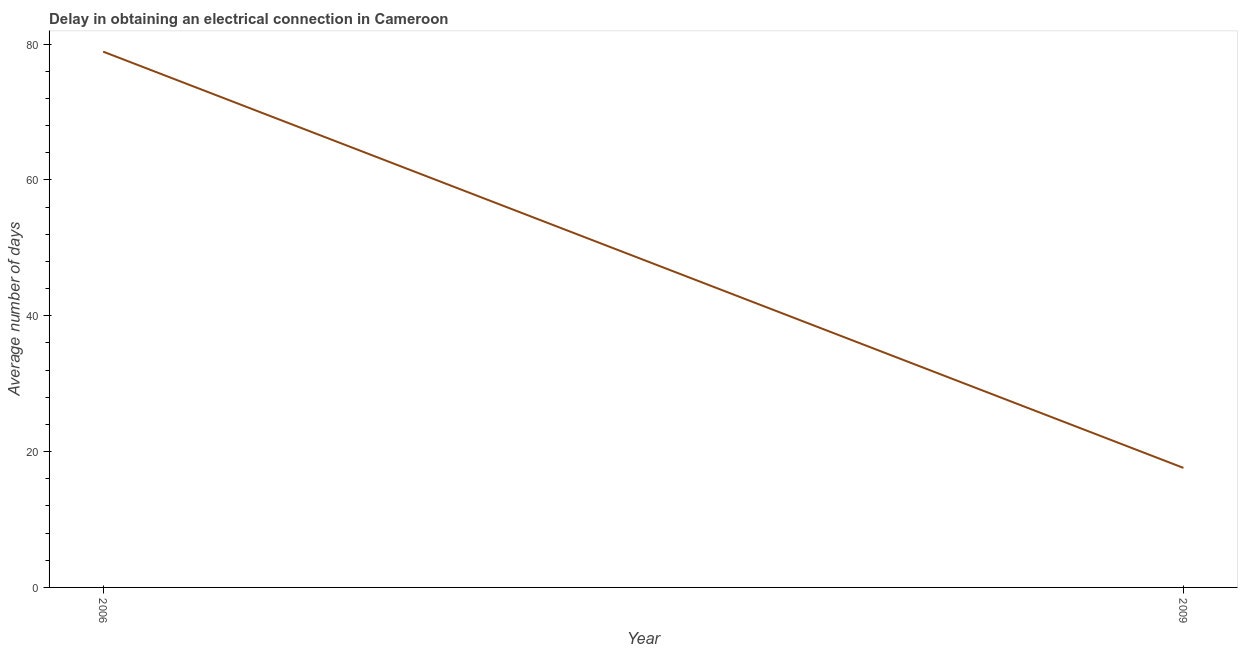Across all years, what is the maximum dalay in electrical connection?
Offer a very short reply. 78.9. In which year was the dalay in electrical connection minimum?
Keep it short and to the point. 2009. What is the sum of the dalay in electrical connection?
Your answer should be compact. 96.5. What is the difference between the dalay in electrical connection in 2006 and 2009?
Your answer should be very brief. 61.3. What is the average dalay in electrical connection per year?
Offer a very short reply. 48.25. What is the median dalay in electrical connection?
Give a very brief answer. 48.25. In how many years, is the dalay in electrical connection greater than 32 days?
Provide a short and direct response. 1. Do a majority of the years between 2009 and 2006 (inclusive) have dalay in electrical connection greater than 52 days?
Keep it short and to the point. No. What is the ratio of the dalay in electrical connection in 2006 to that in 2009?
Ensure brevity in your answer.  4.48. Is the dalay in electrical connection in 2006 less than that in 2009?
Your response must be concise. No. In how many years, is the dalay in electrical connection greater than the average dalay in electrical connection taken over all years?
Provide a succinct answer. 1. How many years are there in the graph?
Keep it short and to the point. 2. What is the difference between two consecutive major ticks on the Y-axis?
Give a very brief answer. 20. Are the values on the major ticks of Y-axis written in scientific E-notation?
Ensure brevity in your answer.  No. Does the graph contain grids?
Make the answer very short. No. What is the title of the graph?
Your answer should be very brief. Delay in obtaining an electrical connection in Cameroon. What is the label or title of the Y-axis?
Provide a short and direct response. Average number of days. What is the Average number of days in 2006?
Provide a succinct answer. 78.9. What is the Average number of days of 2009?
Your answer should be very brief. 17.6. What is the difference between the Average number of days in 2006 and 2009?
Make the answer very short. 61.3. What is the ratio of the Average number of days in 2006 to that in 2009?
Provide a succinct answer. 4.48. 